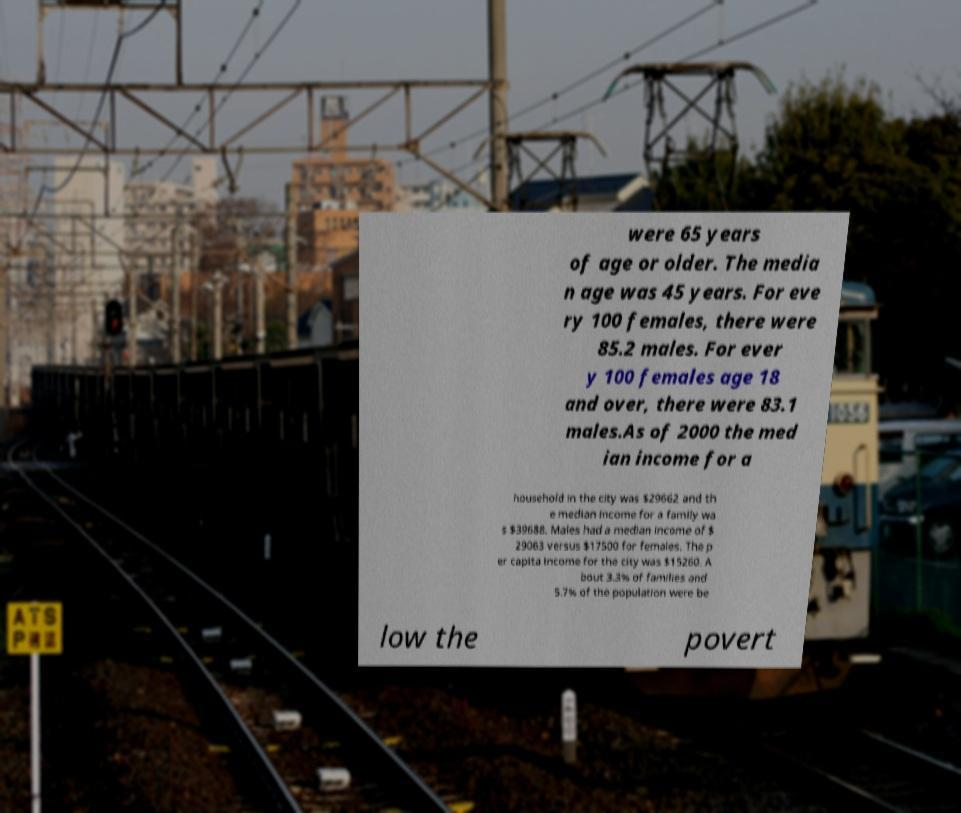Could you extract and type out the text from this image? The text on the paper appears to provide demographic and economic statistics, likely of a city. The extracted text includes details like the median age, gender distribution, and income data. However, the bottom part of the text is obscured, likely continuing the statistics related to poverty rates and possibly additional economic data not fully visible. 